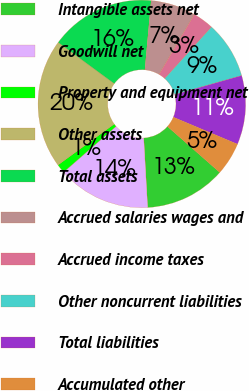Convert chart to OTSL. <chart><loc_0><loc_0><loc_500><loc_500><pie_chart><fcel>Intangible assets net<fcel>Goodwill net<fcel>Property and equipment net<fcel>Other assets<fcel>Total assets<fcel>Accrued salaries wages and<fcel>Accrued income taxes<fcel>Other noncurrent liabilities<fcel>Total liabilities<fcel>Accumulated other<nl><fcel>12.62%<fcel>14.49%<fcel>1.39%<fcel>20.1%<fcel>16.36%<fcel>7.01%<fcel>3.26%<fcel>8.88%<fcel>10.75%<fcel>5.13%<nl></chart> 